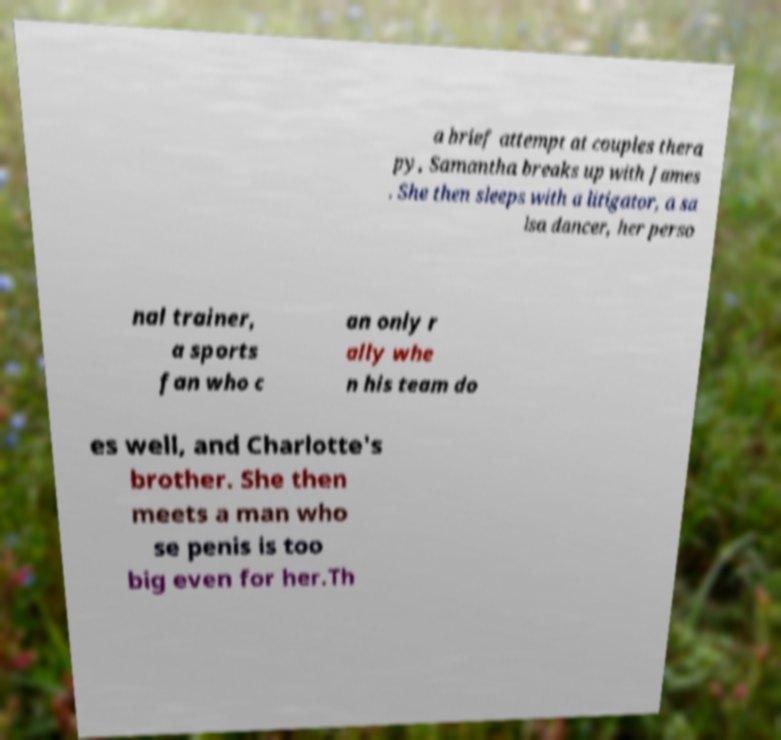Could you extract and type out the text from this image? a brief attempt at couples thera py, Samantha breaks up with James . She then sleeps with a litigator, a sa lsa dancer, her perso nal trainer, a sports fan who c an only r ally whe n his team do es well, and Charlotte's brother. She then meets a man who se penis is too big even for her.Th 